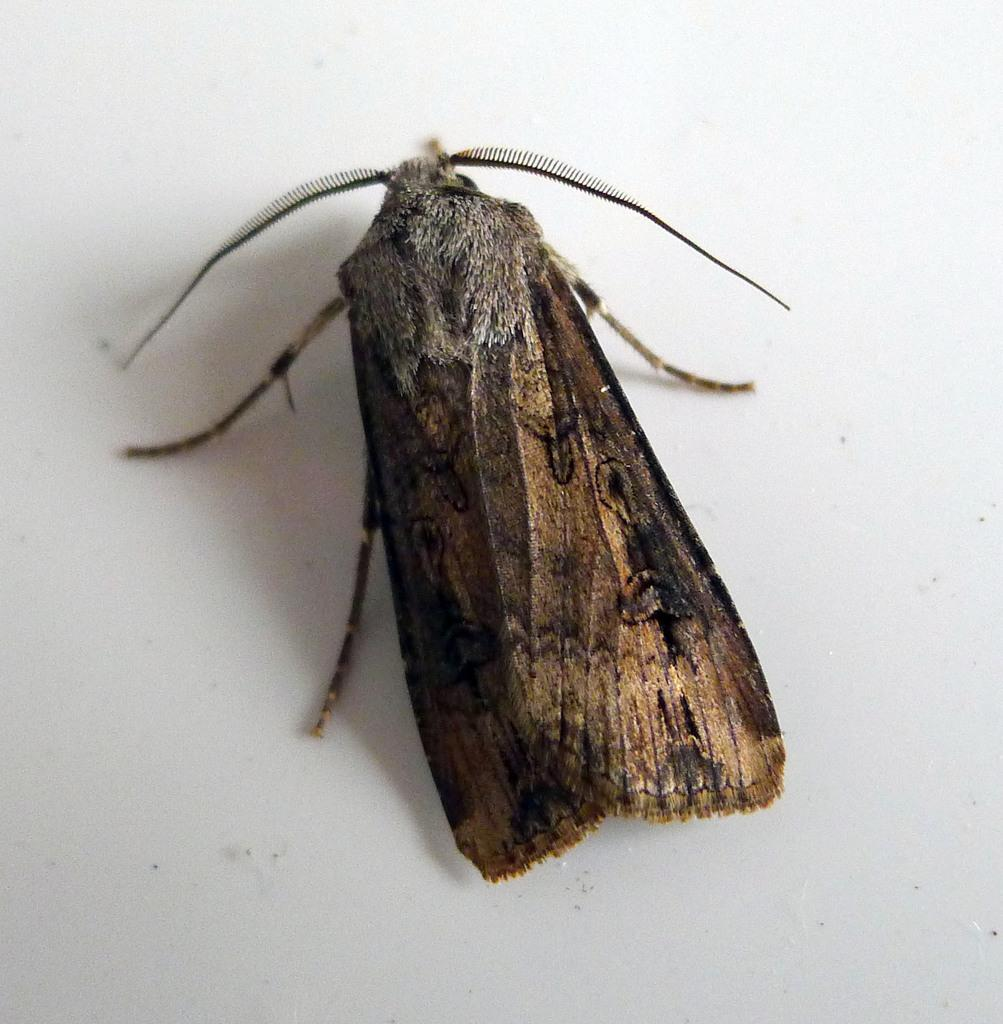What type of creature can be seen in the image? There is an insect in the image. What color is the background of the image? The background of the image is white. What type of writer is depicted in the image? There is no writer present in the image; it features an insect and a white background. What type of land or field can be seen in the image? There is no land or field present in the image; it features an insect and a white background. 